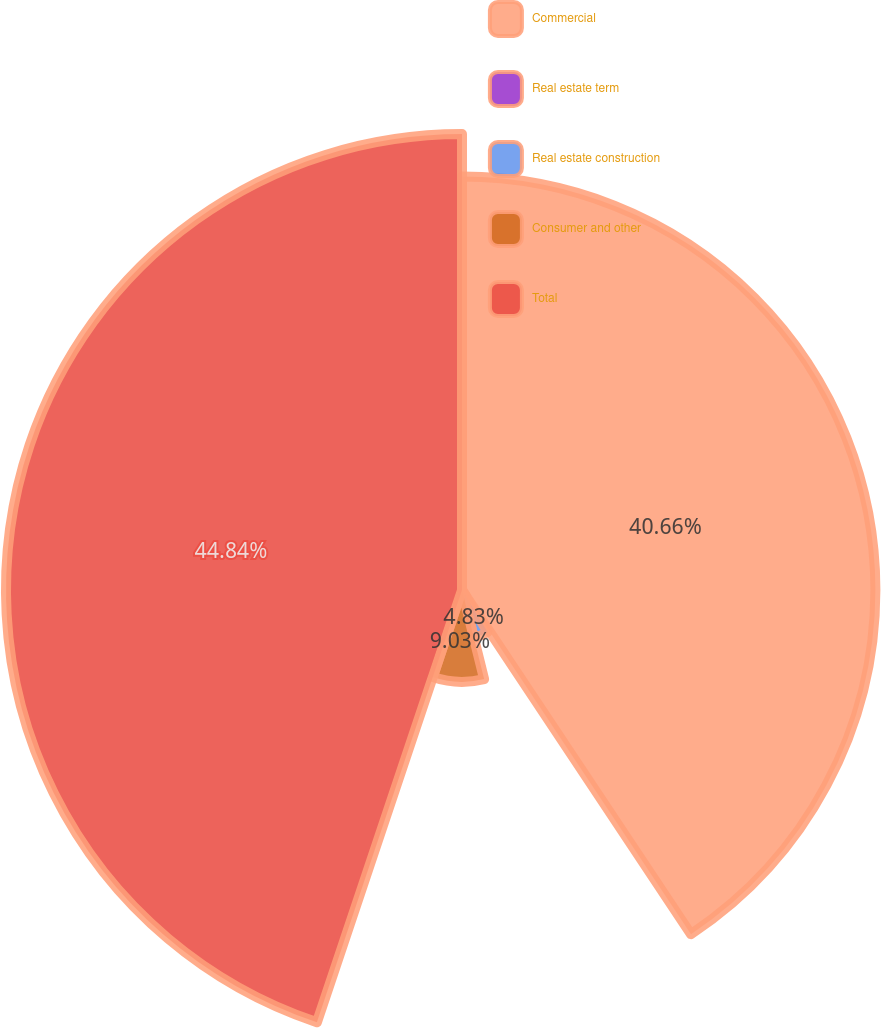Convert chart to OTSL. <chart><loc_0><loc_0><loc_500><loc_500><pie_chart><fcel>Commercial<fcel>Real estate term<fcel>Real estate construction<fcel>Consumer and other<fcel>Total<nl><fcel>40.66%<fcel>0.64%<fcel>4.83%<fcel>9.03%<fcel>44.85%<nl></chart> 